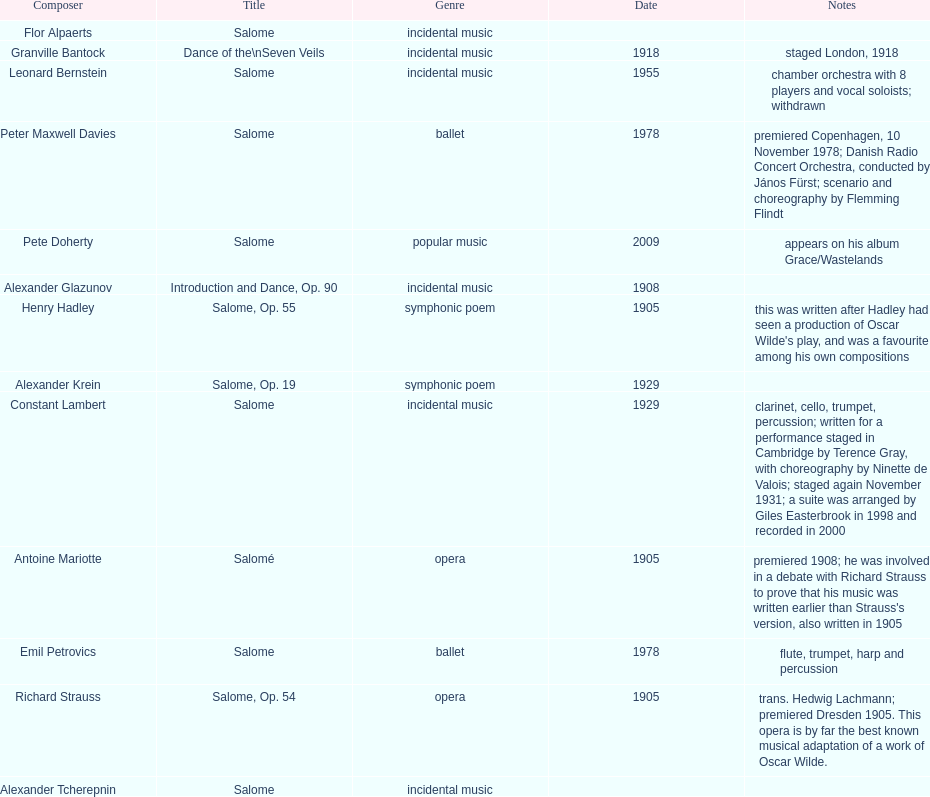In the genre of incidental music, how many pieces were produced? 6. 